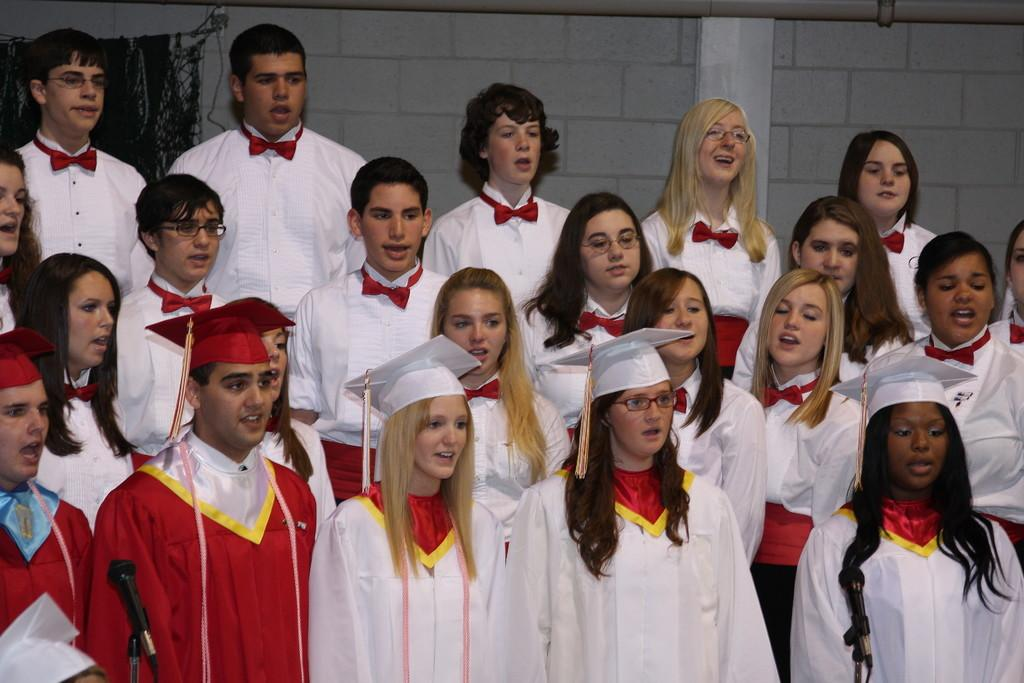What is the main subject of the image? The main subject of the image is a group of people. What are the people in the image doing? The people are standing in the image. What object is present in the image that is typically used for amplifying sound? There is a microphone with a stand in the image. What can be seen in the background of the image? There is a wall in the background of the image. Can you tell me how many kitties are sitting on the train in the image? There are no kitties or trains present in the image; it features a group of people standing with a microphone and a wall in the background. 